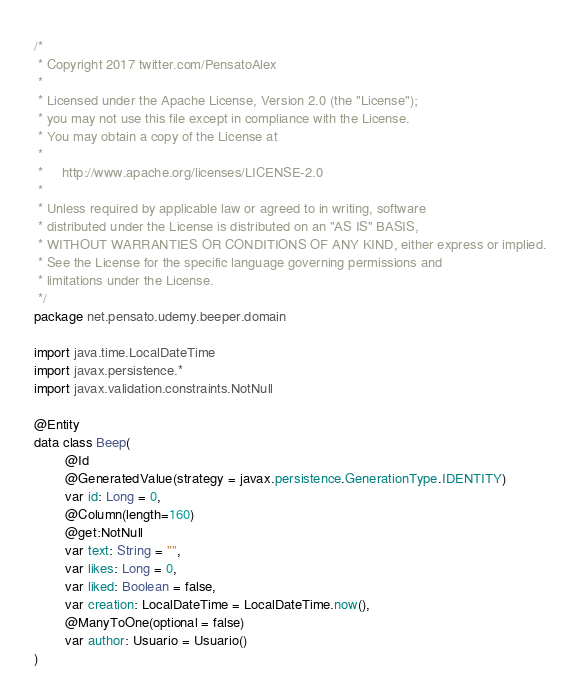Convert code to text. <code><loc_0><loc_0><loc_500><loc_500><_Kotlin_>/*
 * Copyright 2017 twitter.com/PensatoAlex
 *
 * Licensed under the Apache License, Version 2.0 (the "License");
 * you may not use this file except in compliance with the License.
 * You may obtain a copy of the License at
 *
 *     http://www.apache.org/licenses/LICENSE-2.0
 *
 * Unless required by applicable law or agreed to in writing, software
 * distributed under the License is distributed on an "AS IS" BASIS,
 * WITHOUT WARRANTIES OR CONDITIONS OF ANY KIND, either express or implied.
 * See the License for the specific language governing permissions and
 * limitations under the License.
 */
package net.pensato.udemy.beeper.domain

import java.time.LocalDateTime
import javax.persistence.*
import javax.validation.constraints.NotNull

@Entity
data class Beep(
        @Id
        @GeneratedValue(strategy = javax.persistence.GenerationType.IDENTITY)
        var id: Long = 0,
        @Column(length=160)
        @get:NotNull
        var text: String = "",
        var likes: Long = 0,
        var liked: Boolean = false,
        var creation: LocalDateTime = LocalDateTime.now(),
        @ManyToOne(optional = false)
        var author: Usuario = Usuario()
)
</code> 